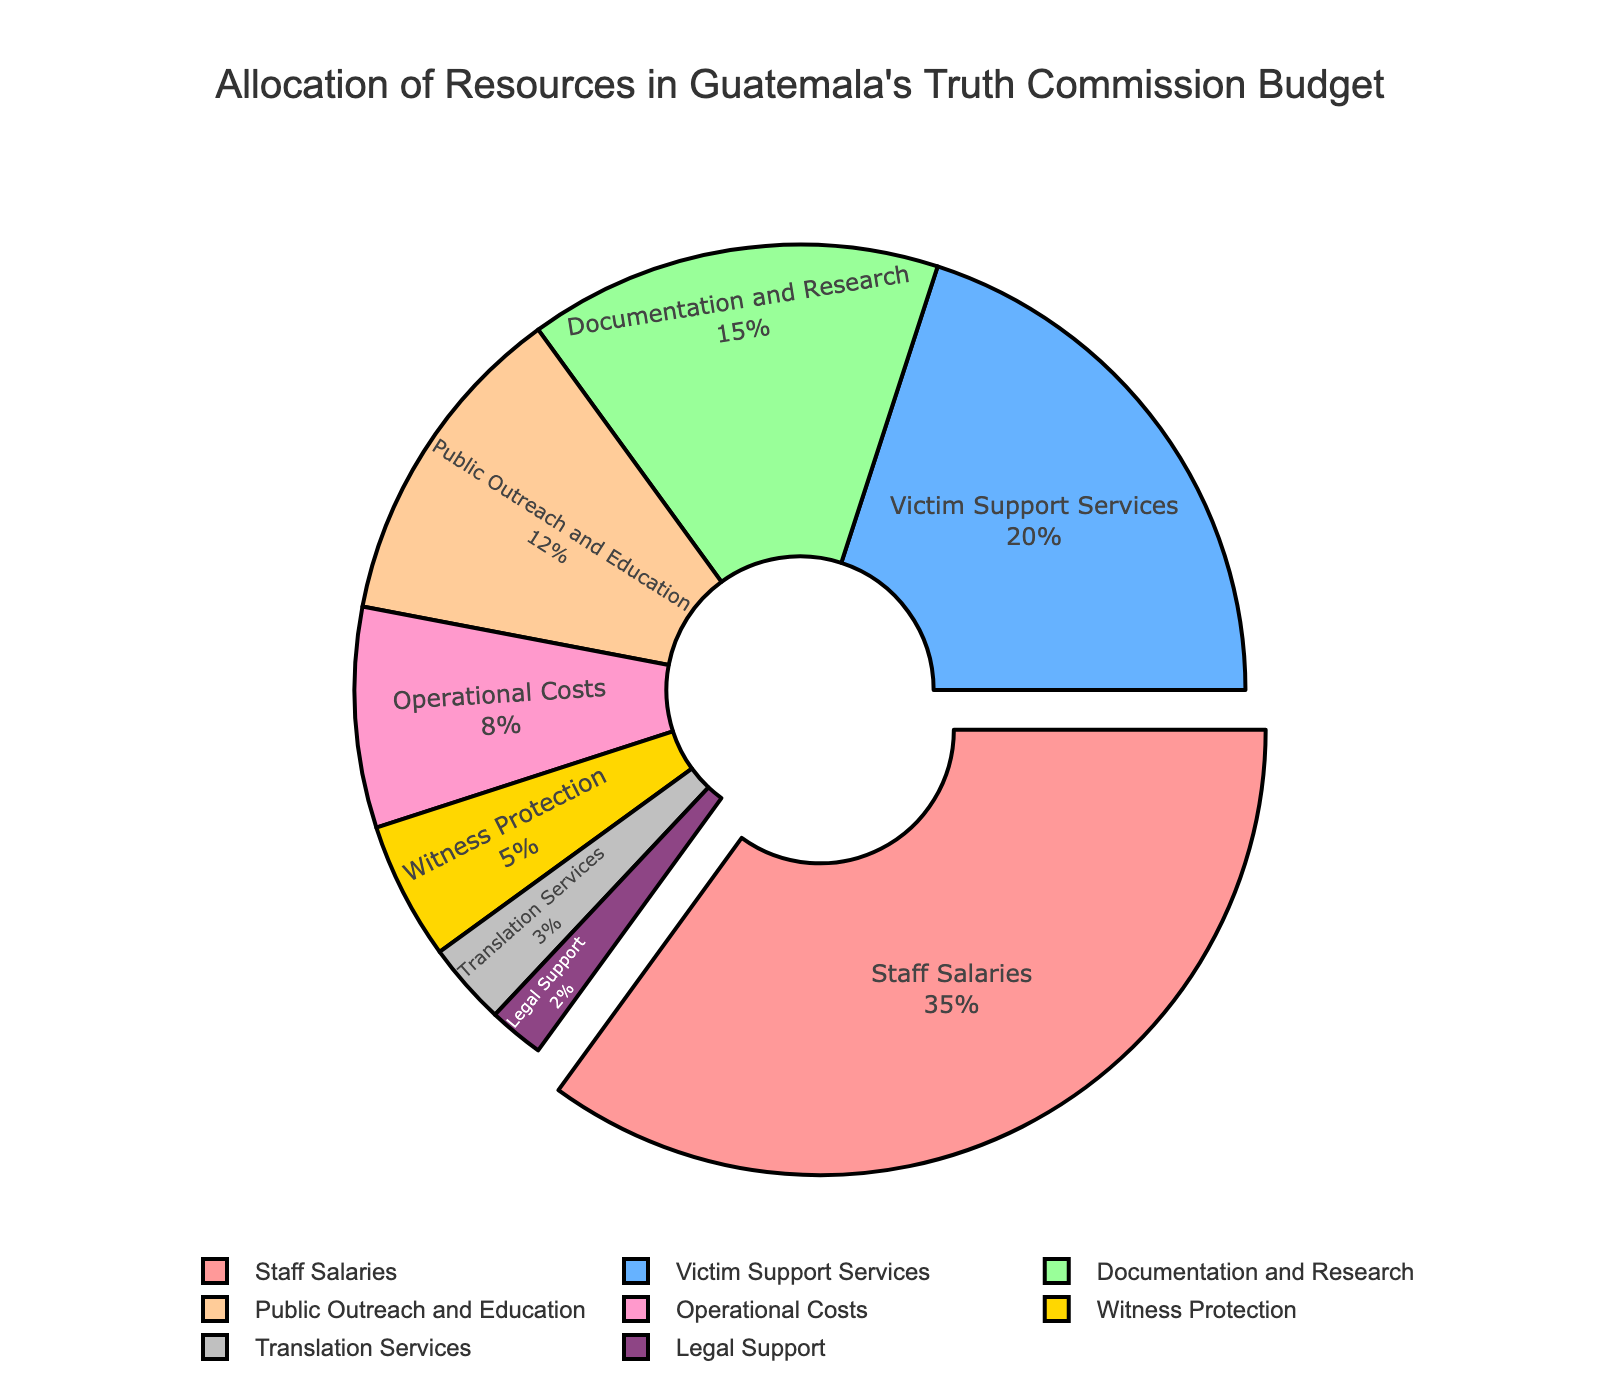What category takes up the largest percentage of Guatemala's truth commission budget? To determine the largest percentage category, we look at the slice that extends outward, which is "Staff Salaries" at 35%. This can also be confirmed from the label + percentage information.
Answer: Staff Salaries Which category is allocated exactly 20% of the resources? By looking at the labels and percentages in the chart, we locate "Victim Support Services" with an allocated percentage of 20%.
Answer: Victim Support Services What is the combined percentage of "Operational Costs" and "Witness Protection"? Locate the percentages for both categories: "Operational Costs" is 8% and "Witness Protection" is 5%. Adding them gives 8% + 5% = 13%.
Answer: 13% What is the difference in percentage between "Documentation and Research" and "Translation Services"? Find the percentages for "Documentation and Research" (15%) and "Translation Services" (3%). Subtract the smaller percentage from the larger: 15% - 3% = 12%.
Answer: 12% Which categories have a combined budget allocation of 25% or higher? Individuals should look for categories whose percentages, when summed, are 25% or higher. "Staff Salaries" alone (35%) meets this criterion. Additionally, "Victim Support Services" (20%) combined with "Documentation and Research" (15%) also sums up to a higher value (20% + 15% = 35%).
Answer: Staff Salaries and Victim Support Services + Documentation and Research Name the categories with percentages lower than 5%. Review the chart for segments labeled with less than 5%. "Translation Services" (3%) and "Legal Support" (2%) meet this criterion.
Answer: Translation Services and Legal Support What category has the smallest allocation in the budget? Identify the category with the smallest pie slice and label, which is "Legal Support" at 2%.
Answer: Legal Support By how much does the "Public Outreach and Education" budget exceed the "Translation Services" budget? Compare the percentages for both categories: "Public Outreach and Education" is 12%, and "Translation Services" is 3%. The difference is 12% - 3% = 9%.
Answer: 9% Which category gets a higher budget allocation: "Operational Costs" or "Witness Protection"? Look at the percentages for "Operational Costs" (8%) and "Witness Protection" (5%). Since 8% is greater than 5%, "Operational Costs" gets a higher allocation.
Answer: Operational Costs Determine the average percentage allocation for "Documentation and Research," "Public Outreach and Education," and "Legal Support." Add the percentages of the three categories and divide by the number of categories: (15% + 12% + 2%) / 3 = 29% / 3 = 9.67%.
Answer: 9.67% 